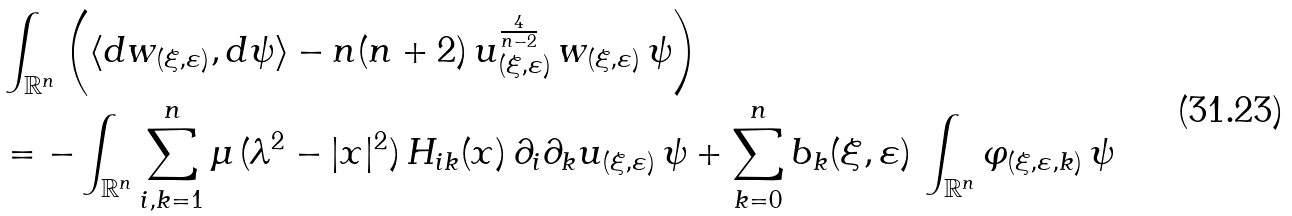Convert formula to latex. <formula><loc_0><loc_0><loc_500><loc_500>& \int _ { \mathbb { R } ^ { n } } \left ( \langle d w _ { ( \xi , \varepsilon ) } , d \psi \rangle - n ( n + 2 ) \, u _ { ( \xi , \varepsilon ) } ^ { \frac { 4 } { n - 2 } } \, w _ { ( \xi , \varepsilon ) } \, \psi \right ) \\ & = - \int _ { \mathbb { R } ^ { n } } \sum _ { i , k = 1 } ^ { n } \mu \, ( \lambda ^ { 2 } - | x | ^ { 2 } ) \, H _ { i k } ( x ) \, \partial _ { i } \partial _ { k } u _ { ( \xi , \varepsilon ) } \, \psi + \sum _ { k = 0 } ^ { n } b _ { k } ( \xi , \varepsilon ) \, \int _ { \mathbb { R } ^ { n } } \varphi _ { ( \xi , \varepsilon , k ) } \, \psi</formula> 